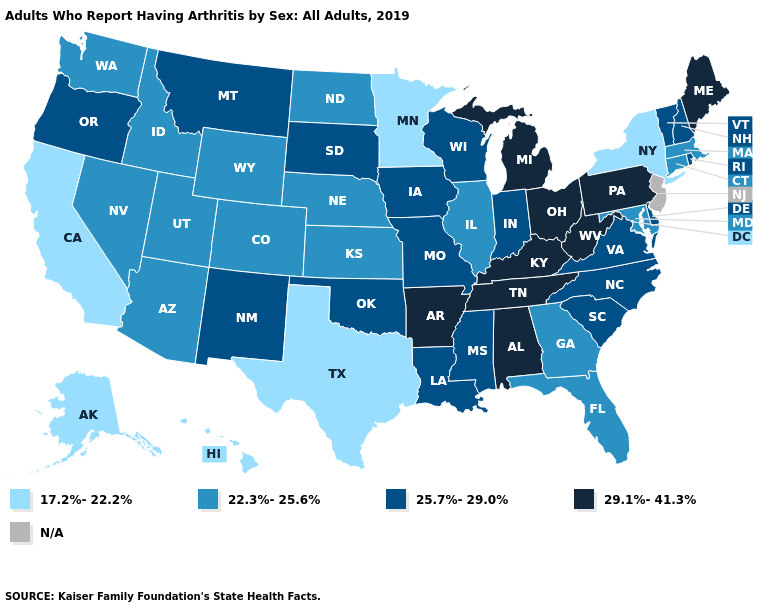What is the value of Georgia?
Be succinct. 22.3%-25.6%. How many symbols are there in the legend?
Answer briefly. 5. What is the highest value in the USA?
Write a very short answer. 29.1%-41.3%. Name the states that have a value in the range 29.1%-41.3%?
Quick response, please. Alabama, Arkansas, Kentucky, Maine, Michigan, Ohio, Pennsylvania, Tennessee, West Virginia. Is the legend a continuous bar?
Give a very brief answer. No. What is the value of Colorado?
Be succinct. 22.3%-25.6%. What is the highest value in states that border Illinois?
Quick response, please. 29.1%-41.3%. What is the value of Georgia?
Short answer required. 22.3%-25.6%. What is the highest value in states that border Michigan?
Give a very brief answer. 29.1%-41.3%. Which states hav the highest value in the West?
Write a very short answer. Montana, New Mexico, Oregon. Which states have the lowest value in the USA?
Give a very brief answer. Alaska, California, Hawaii, Minnesota, New York, Texas. Is the legend a continuous bar?
Be succinct. No. What is the value of South Dakota?
Keep it brief. 25.7%-29.0%. Does the map have missing data?
Give a very brief answer. Yes. How many symbols are there in the legend?
Quick response, please. 5. 